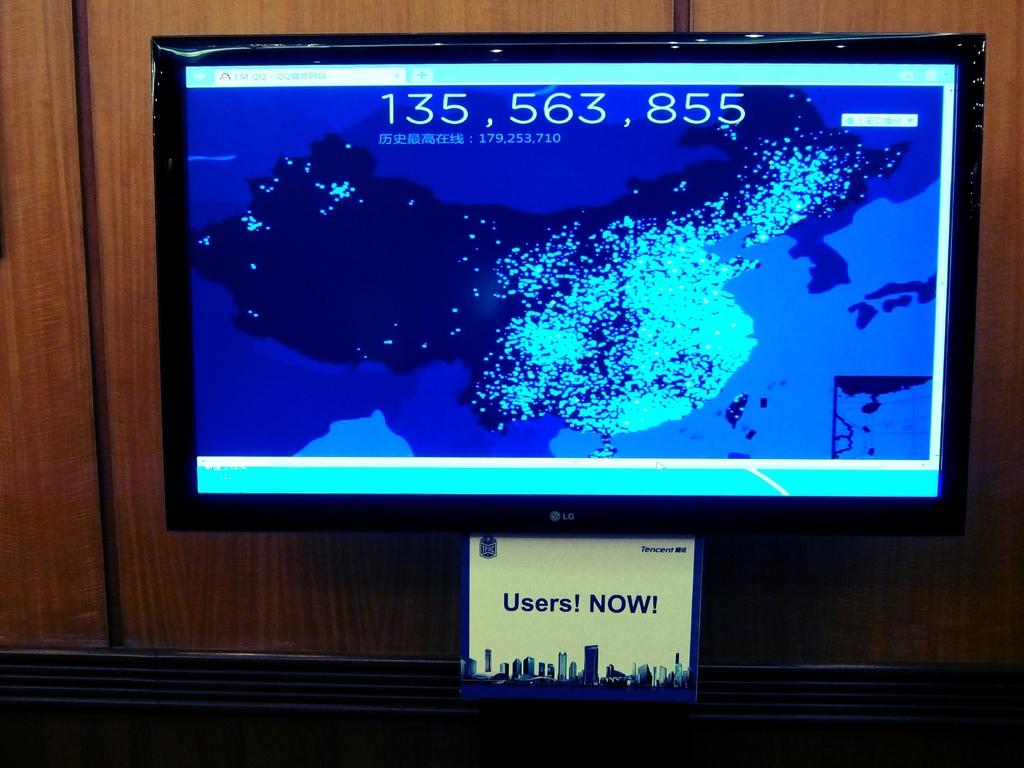Provide a one-sentence caption for the provided image. the number 135 that is on a television screen. 